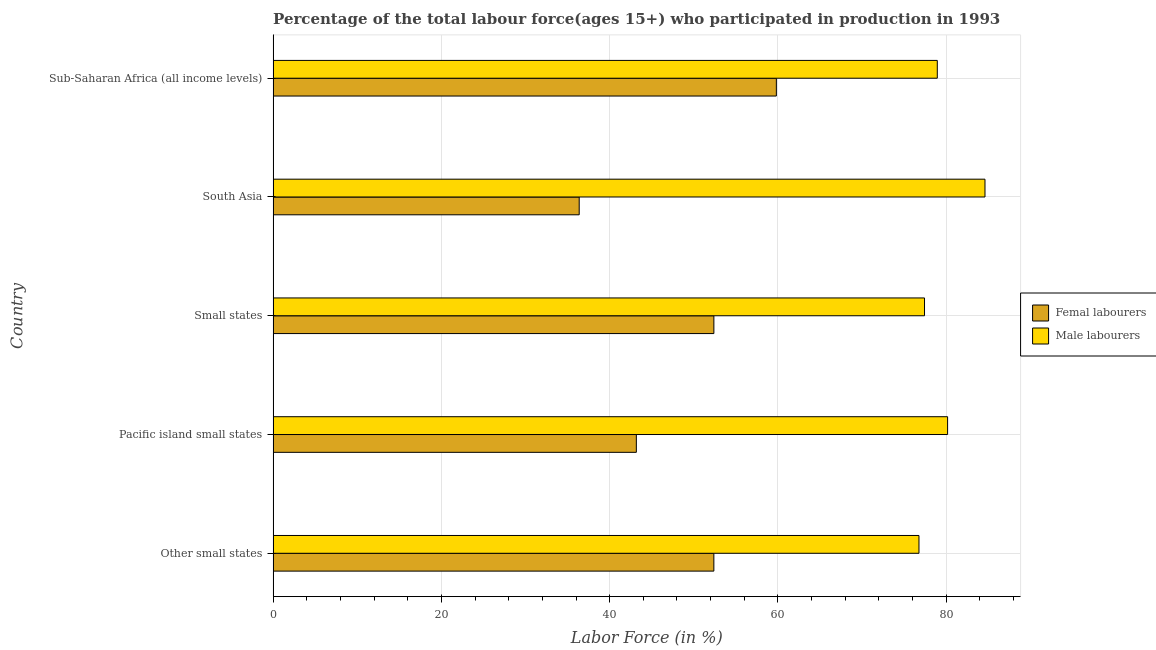How many different coloured bars are there?
Your answer should be very brief. 2. Are the number of bars per tick equal to the number of legend labels?
Your response must be concise. Yes. Are the number of bars on each tick of the Y-axis equal?
Your answer should be very brief. Yes. What is the label of the 5th group of bars from the top?
Your answer should be compact. Other small states. What is the percentage of female labor force in Pacific island small states?
Provide a succinct answer. 43.17. Across all countries, what is the maximum percentage of male labour force?
Provide a short and direct response. 84.6. Across all countries, what is the minimum percentage of female labor force?
Make the answer very short. 36.38. In which country was the percentage of female labor force maximum?
Keep it short and to the point. Sub-Saharan Africa (all income levels). In which country was the percentage of female labor force minimum?
Make the answer very short. South Asia. What is the total percentage of female labor force in the graph?
Make the answer very short. 244.12. What is the difference between the percentage of male labour force in South Asia and that in Sub-Saharan Africa (all income levels)?
Make the answer very short. 5.67. What is the difference between the percentage of female labor force in Small states and the percentage of male labour force in Other small states?
Offer a terse response. -24.38. What is the average percentage of female labor force per country?
Offer a terse response. 48.82. What is the difference between the percentage of male labour force and percentage of female labor force in Small states?
Offer a terse response. 25.04. What is the ratio of the percentage of male labour force in Pacific island small states to that in South Asia?
Offer a terse response. 0.95. What is the difference between the highest and the second highest percentage of female labor force?
Your answer should be compact. 7.43. What is the difference between the highest and the lowest percentage of female labor force?
Your answer should be very brief. 23.43. What does the 2nd bar from the top in Sub-Saharan Africa (all income levels) represents?
Your response must be concise. Femal labourers. What does the 1st bar from the bottom in South Asia represents?
Your answer should be compact. Femal labourers. How many bars are there?
Your answer should be compact. 10. Are all the bars in the graph horizontal?
Offer a terse response. Yes. How many countries are there in the graph?
Keep it short and to the point. 5. Are the values on the major ticks of X-axis written in scientific E-notation?
Provide a short and direct response. No. Where does the legend appear in the graph?
Provide a short and direct response. Center right. How many legend labels are there?
Give a very brief answer. 2. What is the title of the graph?
Offer a very short reply. Percentage of the total labour force(ages 15+) who participated in production in 1993. Does "Urban" appear as one of the legend labels in the graph?
Give a very brief answer. No. What is the label or title of the Y-axis?
Keep it short and to the point. Country. What is the Labor Force (in %) of Femal labourers in Other small states?
Offer a very short reply. 52.38. What is the Labor Force (in %) in Male labourers in Other small states?
Your response must be concise. 76.76. What is the Labor Force (in %) of Femal labourers in Pacific island small states?
Your answer should be compact. 43.17. What is the Labor Force (in %) of Male labourers in Pacific island small states?
Ensure brevity in your answer.  80.16. What is the Labor Force (in %) of Femal labourers in Small states?
Provide a short and direct response. 52.38. What is the Labor Force (in %) in Male labourers in Small states?
Your answer should be compact. 77.42. What is the Labor Force (in %) in Femal labourers in South Asia?
Provide a succinct answer. 36.38. What is the Labor Force (in %) of Male labourers in South Asia?
Ensure brevity in your answer.  84.6. What is the Labor Force (in %) in Femal labourers in Sub-Saharan Africa (all income levels)?
Your response must be concise. 59.81. What is the Labor Force (in %) of Male labourers in Sub-Saharan Africa (all income levels)?
Your response must be concise. 78.94. Across all countries, what is the maximum Labor Force (in %) of Femal labourers?
Give a very brief answer. 59.81. Across all countries, what is the maximum Labor Force (in %) of Male labourers?
Provide a short and direct response. 84.6. Across all countries, what is the minimum Labor Force (in %) in Femal labourers?
Ensure brevity in your answer.  36.38. Across all countries, what is the minimum Labor Force (in %) in Male labourers?
Provide a short and direct response. 76.76. What is the total Labor Force (in %) in Femal labourers in the graph?
Provide a short and direct response. 244.12. What is the total Labor Force (in %) of Male labourers in the graph?
Your response must be concise. 397.88. What is the difference between the Labor Force (in %) of Femal labourers in Other small states and that in Pacific island small states?
Provide a short and direct response. 9.21. What is the difference between the Labor Force (in %) of Male labourers in Other small states and that in Pacific island small states?
Give a very brief answer. -3.4. What is the difference between the Labor Force (in %) of Femal labourers in Other small states and that in Small states?
Ensure brevity in your answer.  -0. What is the difference between the Labor Force (in %) in Male labourers in Other small states and that in Small states?
Ensure brevity in your answer.  -0.66. What is the difference between the Labor Force (in %) in Femal labourers in Other small states and that in South Asia?
Keep it short and to the point. 16. What is the difference between the Labor Force (in %) in Male labourers in Other small states and that in South Asia?
Give a very brief answer. -7.84. What is the difference between the Labor Force (in %) in Femal labourers in Other small states and that in Sub-Saharan Africa (all income levels)?
Your answer should be compact. -7.43. What is the difference between the Labor Force (in %) of Male labourers in Other small states and that in Sub-Saharan Africa (all income levels)?
Provide a succinct answer. -2.18. What is the difference between the Labor Force (in %) in Femal labourers in Pacific island small states and that in Small states?
Ensure brevity in your answer.  -9.21. What is the difference between the Labor Force (in %) of Male labourers in Pacific island small states and that in Small states?
Keep it short and to the point. 2.74. What is the difference between the Labor Force (in %) of Femal labourers in Pacific island small states and that in South Asia?
Your answer should be very brief. 6.79. What is the difference between the Labor Force (in %) in Male labourers in Pacific island small states and that in South Asia?
Make the answer very short. -4.44. What is the difference between the Labor Force (in %) of Femal labourers in Pacific island small states and that in Sub-Saharan Africa (all income levels)?
Give a very brief answer. -16.64. What is the difference between the Labor Force (in %) in Male labourers in Pacific island small states and that in Sub-Saharan Africa (all income levels)?
Your response must be concise. 1.22. What is the difference between the Labor Force (in %) of Femal labourers in Small states and that in South Asia?
Offer a very short reply. 16.01. What is the difference between the Labor Force (in %) of Male labourers in Small states and that in South Asia?
Offer a terse response. -7.19. What is the difference between the Labor Force (in %) of Femal labourers in Small states and that in Sub-Saharan Africa (all income levels)?
Offer a very short reply. -7.43. What is the difference between the Labor Force (in %) of Male labourers in Small states and that in Sub-Saharan Africa (all income levels)?
Your answer should be compact. -1.52. What is the difference between the Labor Force (in %) in Femal labourers in South Asia and that in Sub-Saharan Africa (all income levels)?
Your response must be concise. -23.43. What is the difference between the Labor Force (in %) in Male labourers in South Asia and that in Sub-Saharan Africa (all income levels)?
Provide a succinct answer. 5.67. What is the difference between the Labor Force (in %) of Femal labourers in Other small states and the Labor Force (in %) of Male labourers in Pacific island small states?
Provide a short and direct response. -27.78. What is the difference between the Labor Force (in %) of Femal labourers in Other small states and the Labor Force (in %) of Male labourers in Small states?
Your answer should be compact. -25.04. What is the difference between the Labor Force (in %) in Femal labourers in Other small states and the Labor Force (in %) in Male labourers in South Asia?
Offer a very short reply. -32.22. What is the difference between the Labor Force (in %) of Femal labourers in Other small states and the Labor Force (in %) of Male labourers in Sub-Saharan Africa (all income levels)?
Offer a very short reply. -26.56. What is the difference between the Labor Force (in %) of Femal labourers in Pacific island small states and the Labor Force (in %) of Male labourers in Small states?
Give a very brief answer. -34.25. What is the difference between the Labor Force (in %) in Femal labourers in Pacific island small states and the Labor Force (in %) in Male labourers in South Asia?
Ensure brevity in your answer.  -41.43. What is the difference between the Labor Force (in %) in Femal labourers in Pacific island small states and the Labor Force (in %) in Male labourers in Sub-Saharan Africa (all income levels)?
Offer a terse response. -35.77. What is the difference between the Labor Force (in %) in Femal labourers in Small states and the Labor Force (in %) in Male labourers in South Asia?
Keep it short and to the point. -32.22. What is the difference between the Labor Force (in %) in Femal labourers in Small states and the Labor Force (in %) in Male labourers in Sub-Saharan Africa (all income levels)?
Offer a terse response. -26.55. What is the difference between the Labor Force (in %) in Femal labourers in South Asia and the Labor Force (in %) in Male labourers in Sub-Saharan Africa (all income levels)?
Provide a short and direct response. -42.56. What is the average Labor Force (in %) of Femal labourers per country?
Give a very brief answer. 48.82. What is the average Labor Force (in %) in Male labourers per country?
Make the answer very short. 79.58. What is the difference between the Labor Force (in %) of Femal labourers and Labor Force (in %) of Male labourers in Other small states?
Your answer should be very brief. -24.38. What is the difference between the Labor Force (in %) of Femal labourers and Labor Force (in %) of Male labourers in Pacific island small states?
Your answer should be very brief. -36.99. What is the difference between the Labor Force (in %) in Femal labourers and Labor Force (in %) in Male labourers in Small states?
Make the answer very short. -25.04. What is the difference between the Labor Force (in %) of Femal labourers and Labor Force (in %) of Male labourers in South Asia?
Make the answer very short. -48.23. What is the difference between the Labor Force (in %) of Femal labourers and Labor Force (in %) of Male labourers in Sub-Saharan Africa (all income levels)?
Your answer should be compact. -19.13. What is the ratio of the Labor Force (in %) in Femal labourers in Other small states to that in Pacific island small states?
Your answer should be compact. 1.21. What is the ratio of the Labor Force (in %) in Male labourers in Other small states to that in Pacific island small states?
Offer a very short reply. 0.96. What is the ratio of the Labor Force (in %) in Femal labourers in Other small states to that in Small states?
Keep it short and to the point. 1. What is the ratio of the Labor Force (in %) in Femal labourers in Other small states to that in South Asia?
Your response must be concise. 1.44. What is the ratio of the Labor Force (in %) of Male labourers in Other small states to that in South Asia?
Your answer should be compact. 0.91. What is the ratio of the Labor Force (in %) of Femal labourers in Other small states to that in Sub-Saharan Africa (all income levels)?
Your answer should be very brief. 0.88. What is the ratio of the Labor Force (in %) of Male labourers in Other small states to that in Sub-Saharan Africa (all income levels)?
Make the answer very short. 0.97. What is the ratio of the Labor Force (in %) in Femal labourers in Pacific island small states to that in Small states?
Ensure brevity in your answer.  0.82. What is the ratio of the Labor Force (in %) of Male labourers in Pacific island small states to that in Small states?
Your answer should be compact. 1.04. What is the ratio of the Labor Force (in %) of Femal labourers in Pacific island small states to that in South Asia?
Give a very brief answer. 1.19. What is the ratio of the Labor Force (in %) of Male labourers in Pacific island small states to that in South Asia?
Keep it short and to the point. 0.95. What is the ratio of the Labor Force (in %) of Femal labourers in Pacific island small states to that in Sub-Saharan Africa (all income levels)?
Offer a very short reply. 0.72. What is the ratio of the Labor Force (in %) of Male labourers in Pacific island small states to that in Sub-Saharan Africa (all income levels)?
Give a very brief answer. 1.02. What is the ratio of the Labor Force (in %) of Femal labourers in Small states to that in South Asia?
Provide a short and direct response. 1.44. What is the ratio of the Labor Force (in %) of Male labourers in Small states to that in South Asia?
Offer a very short reply. 0.92. What is the ratio of the Labor Force (in %) of Femal labourers in Small states to that in Sub-Saharan Africa (all income levels)?
Keep it short and to the point. 0.88. What is the ratio of the Labor Force (in %) in Male labourers in Small states to that in Sub-Saharan Africa (all income levels)?
Your answer should be very brief. 0.98. What is the ratio of the Labor Force (in %) in Femal labourers in South Asia to that in Sub-Saharan Africa (all income levels)?
Provide a short and direct response. 0.61. What is the ratio of the Labor Force (in %) in Male labourers in South Asia to that in Sub-Saharan Africa (all income levels)?
Offer a terse response. 1.07. What is the difference between the highest and the second highest Labor Force (in %) in Femal labourers?
Give a very brief answer. 7.43. What is the difference between the highest and the second highest Labor Force (in %) in Male labourers?
Offer a very short reply. 4.44. What is the difference between the highest and the lowest Labor Force (in %) of Femal labourers?
Offer a terse response. 23.43. What is the difference between the highest and the lowest Labor Force (in %) of Male labourers?
Keep it short and to the point. 7.84. 